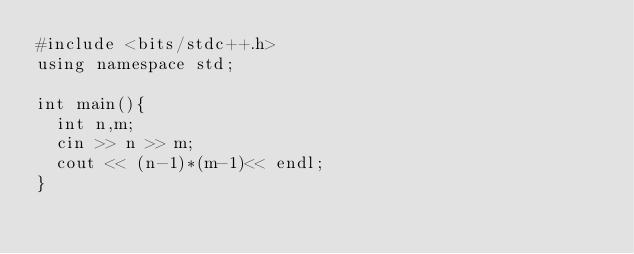<code> <loc_0><loc_0><loc_500><loc_500><_C++_>#include <bits/stdc++.h>
using namespace std;

int main(){
  int n,m;
  cin >> n >> m;
  cout << (n-1)*(m-1)<< endl;
}</code> 